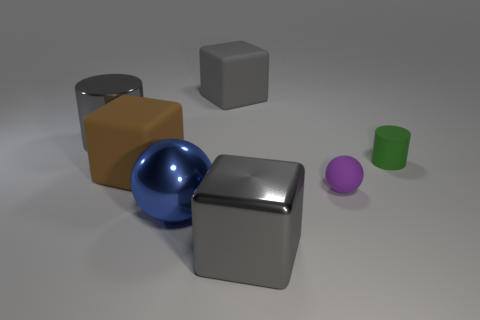Add 1 big blue metal cylinders. How many objects exist? 8 Subtract all large gray matte blocks. How many blocks are left? 2 Subtract 2 spheres. How many spheres are left? 0 Subtract all red cylinders. Subtract all blue balls. How many cylinders are left? 2 Subtract all green cylinders. How many cylinders are left? 1 Subtract all cubes. How many objects are left? 4 Subtract all green cylinders. How many cyan balls are left? 0 Subtract all gray things. Subtract all tiny cylinders. How many objects are left? 3 Add 2 gray cylinders. How many gray cylinders are left? 3 Add 6 big green metal cubes. How many big green metal cubes exist? 6 